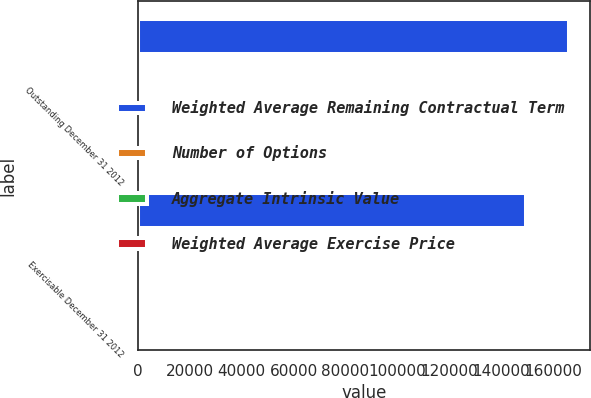Convert chart. <chart><loc_0><loc_0><loc_500><loc_500><stacked_bar_chart><ecel><fcel>Outstanding December 31 2012<fcel>Exercisable December 31 2012<nl><fcel>Weighted Average Remaining Contractual Term<fcel>165941<fcel>149407<nl><fcel>Number of Options<fcel>39.46<fcel>39.64<nl><fcel>Aggregate Intrinsic Value<fcel>3.9<fcel>3.45<nl><fcel>Weighted Average Exercise Price<fcel>762<fcel>700<nl></chart> 